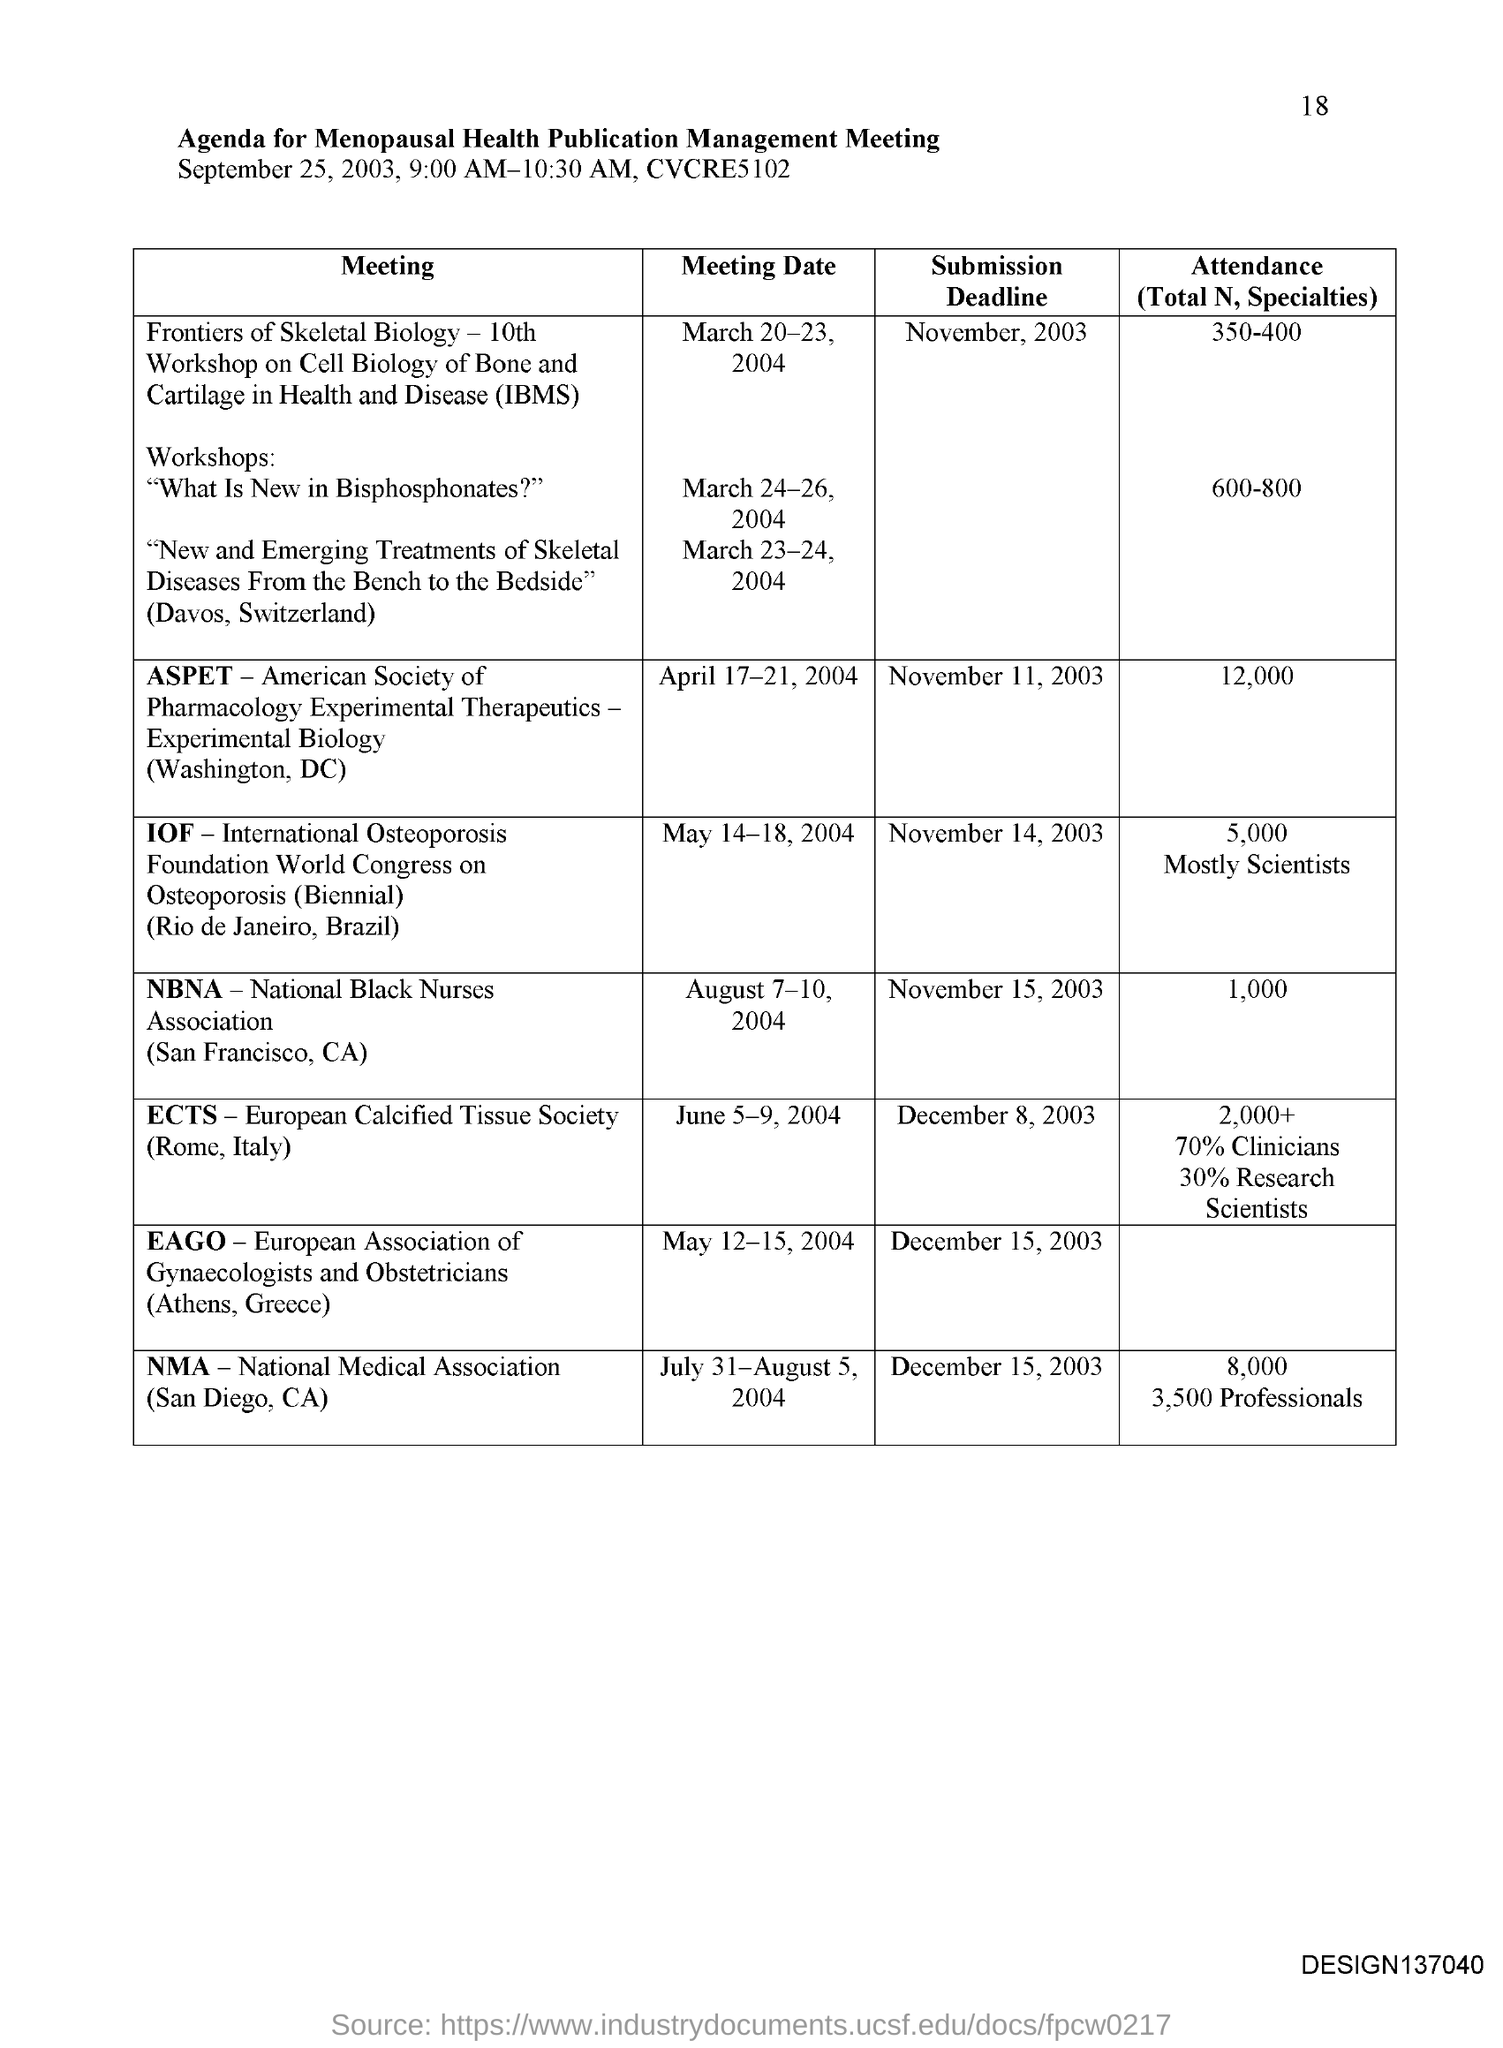What type of Agenda is this ?
Provide a succinct answer. Agenda for Menopausal Health Publication Management Meeting. What is the Abbreviation for IOF ?
Offer a terse response. International Osteoporosis Foundation. What is the Attendance result for NBNA ?
Your response must be concise. 1,000. What is the Abbreviation for NMA ?
Your answer should be very brief. National Medical Association. What is the Submission Date for IOF ?
Ensure brevity in your answer.  November 14, 2003. What is the Abbreviation for NBNA ?
Your response must be concise. National Black Nurses Association. What is the Meeting Date for ASPET  ?
Make the answer very short. April 17-21, 2004. What is the Abbreviation for ECTS ?
Your response must be concise. European Calcified Tissue Society. When is the Submission date for EAGO ?
Your response must be concise. December 15, 2003. When is the Meeting Date for NBNA ?
Give a very brief answer. August 7-10, 2004. 